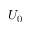Convert formula to latex. <formula><loc_0><loc_0><loc_500><loc_500>U _ { 0 }</formula> 